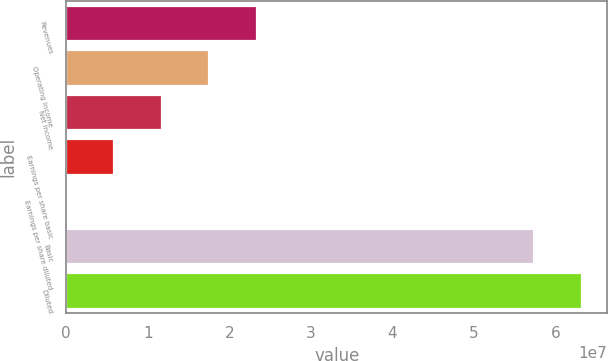Convert chart to OTSL. <chart><loc_0><loc_0><loc_500><loc_500><bar_chart><fcel>Revenues<fcel>Operating income<fcel>Net income<fcel>Earnings per share basic<fcel>Earnings per share diluted<fcel>Basic<fcel>Diluted<nl><fcel>2.34104e+07<fcel>1.75578e+07<fcel>1.17052e+07<fcel>5.8526e+06<fcel>0.57<fcel>5.73072e+07<fcel>6.31598e+07<nl></chart> 